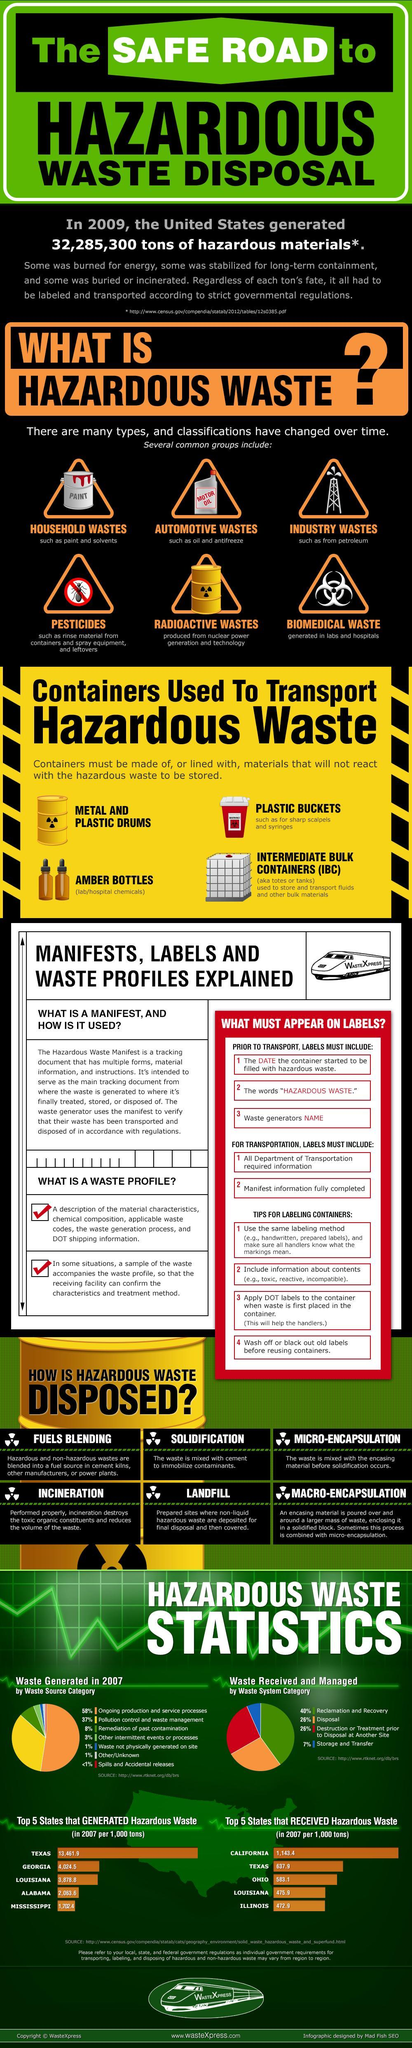How many common groups of Hazardous wastes are listed in the image?
Answer the question with a short phrase. 6 What type of waste are generated from laboratories, Radioactive waste, Biomedical waste, or Industry waste ? Biomedical waste How many types of containers are listed in the image that are used to transporting hazardous waste? 4 